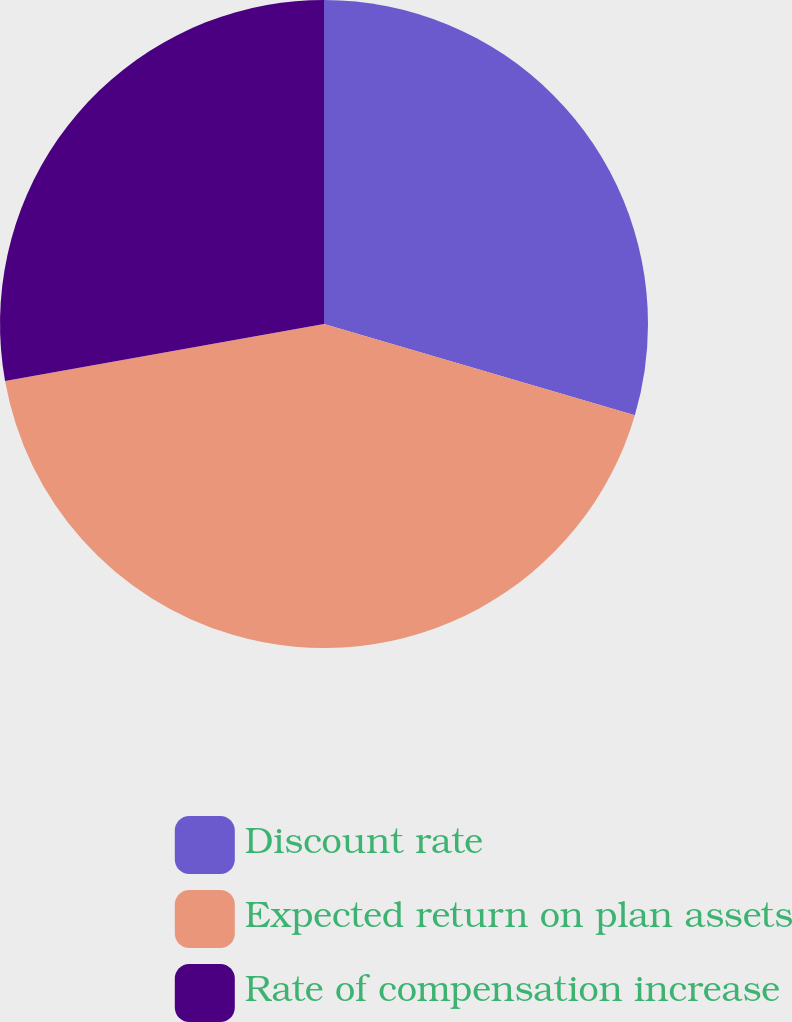Convert chart to OTSL. <chart><loc_0><loc_0><loc_500><loc_500><pie_chart><fcel>Discount rate<fcel>Expected return on plan assets<fcel>Rate of compensation increase<nl><fcel>29.55%<fcel>42.63%<fcel>27.82%<nl></chart> 